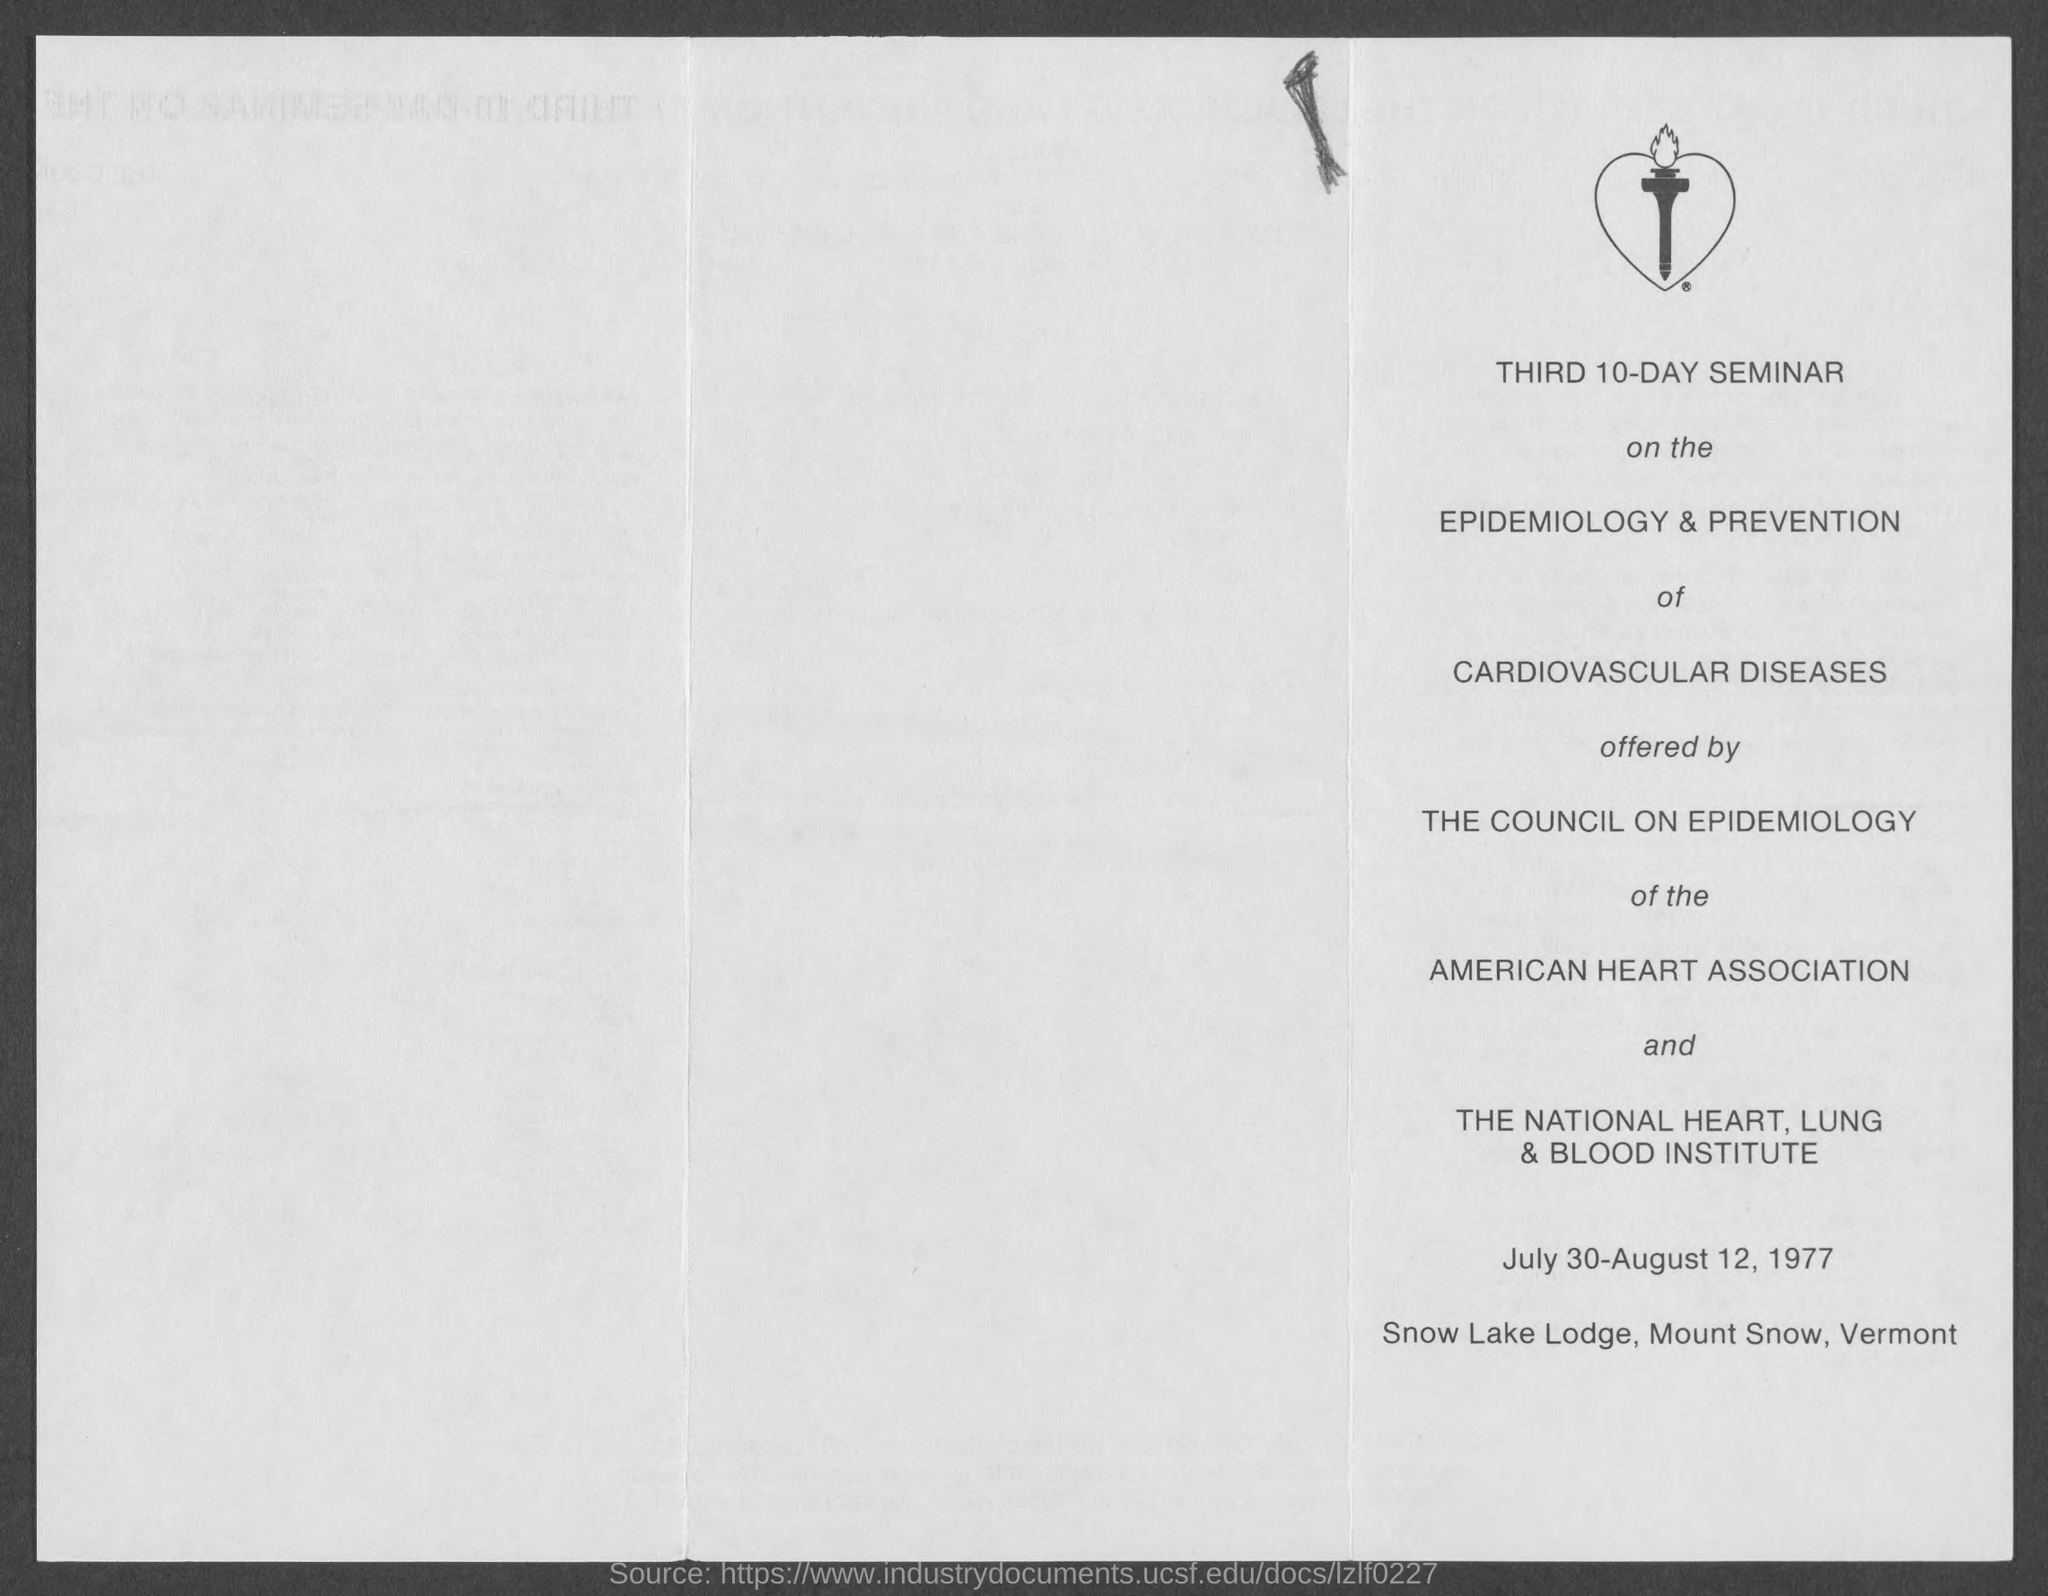Who offered the seminar ?
Offer a terse response. THE COUNCIL ON EPIDEMIOLOGY. Where the seminar is conducted ?
Your answer should be compact. Snow Lake Lodge, Mount Snow, Vermont. Which association has the power over " The Council On Epidemiology" ?
Make the answer very short. AMERICAN HEART ASSOCIATION. Which Institute has the power over " The Council On Epidemiology" ?
Give a very brief answer. THE NATIONAL HEART, LUNG & BLOOD INSTITUTE. What type of disease is discussed in the seminar?
Your answer should be very brief. CARDIOVASCULAR DISEASES. 